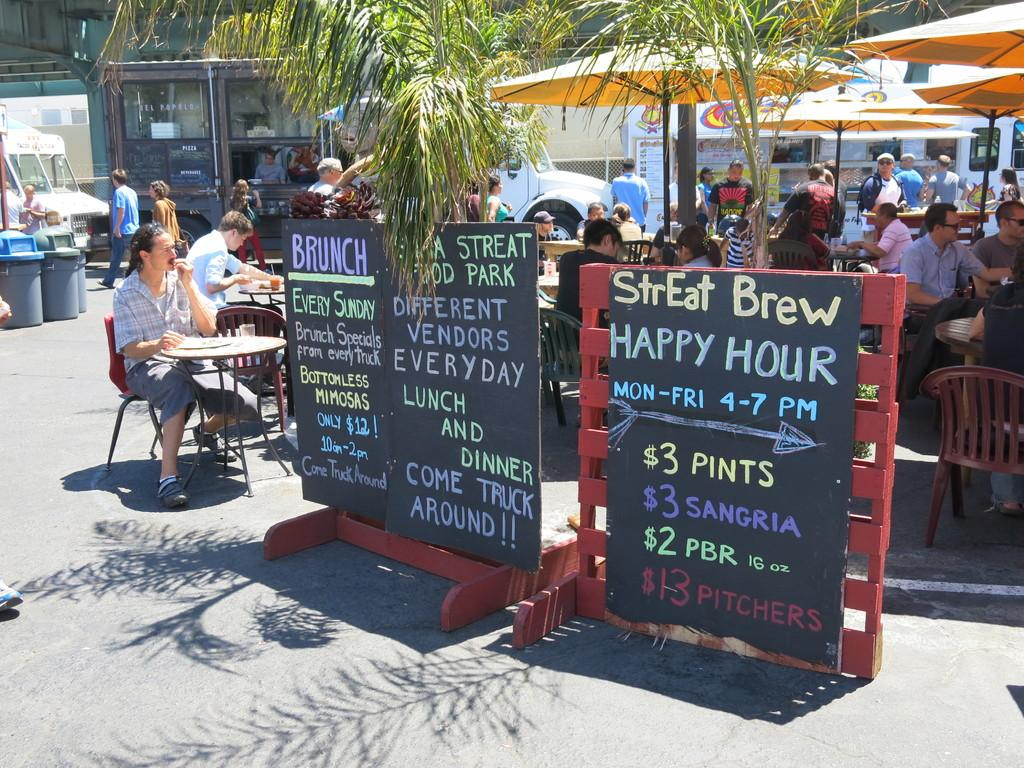How many people are in the image? There is a group of people in the image. What are the people doing in the image? The people are sitting on chairs. Where are the chairs located in relation to the table? The chairs are in front of a table. What is on the road in the image? There is a board on the road in the image. What type of vegetation can be seen in the image? There is a tree visible in the image. What angle does the system take in the image? There is no system present in the image, so it is not possible to determine the angle it might take. 